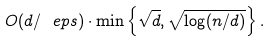Convert formula to latex. <formula><loc_0><loc_0><loc_500><loc_500>O ( d / \ e p s ) \cdot \min \left \{ \sqrt { d } , \sqrt { \log ( n / d ) } \right \} .</formula> 